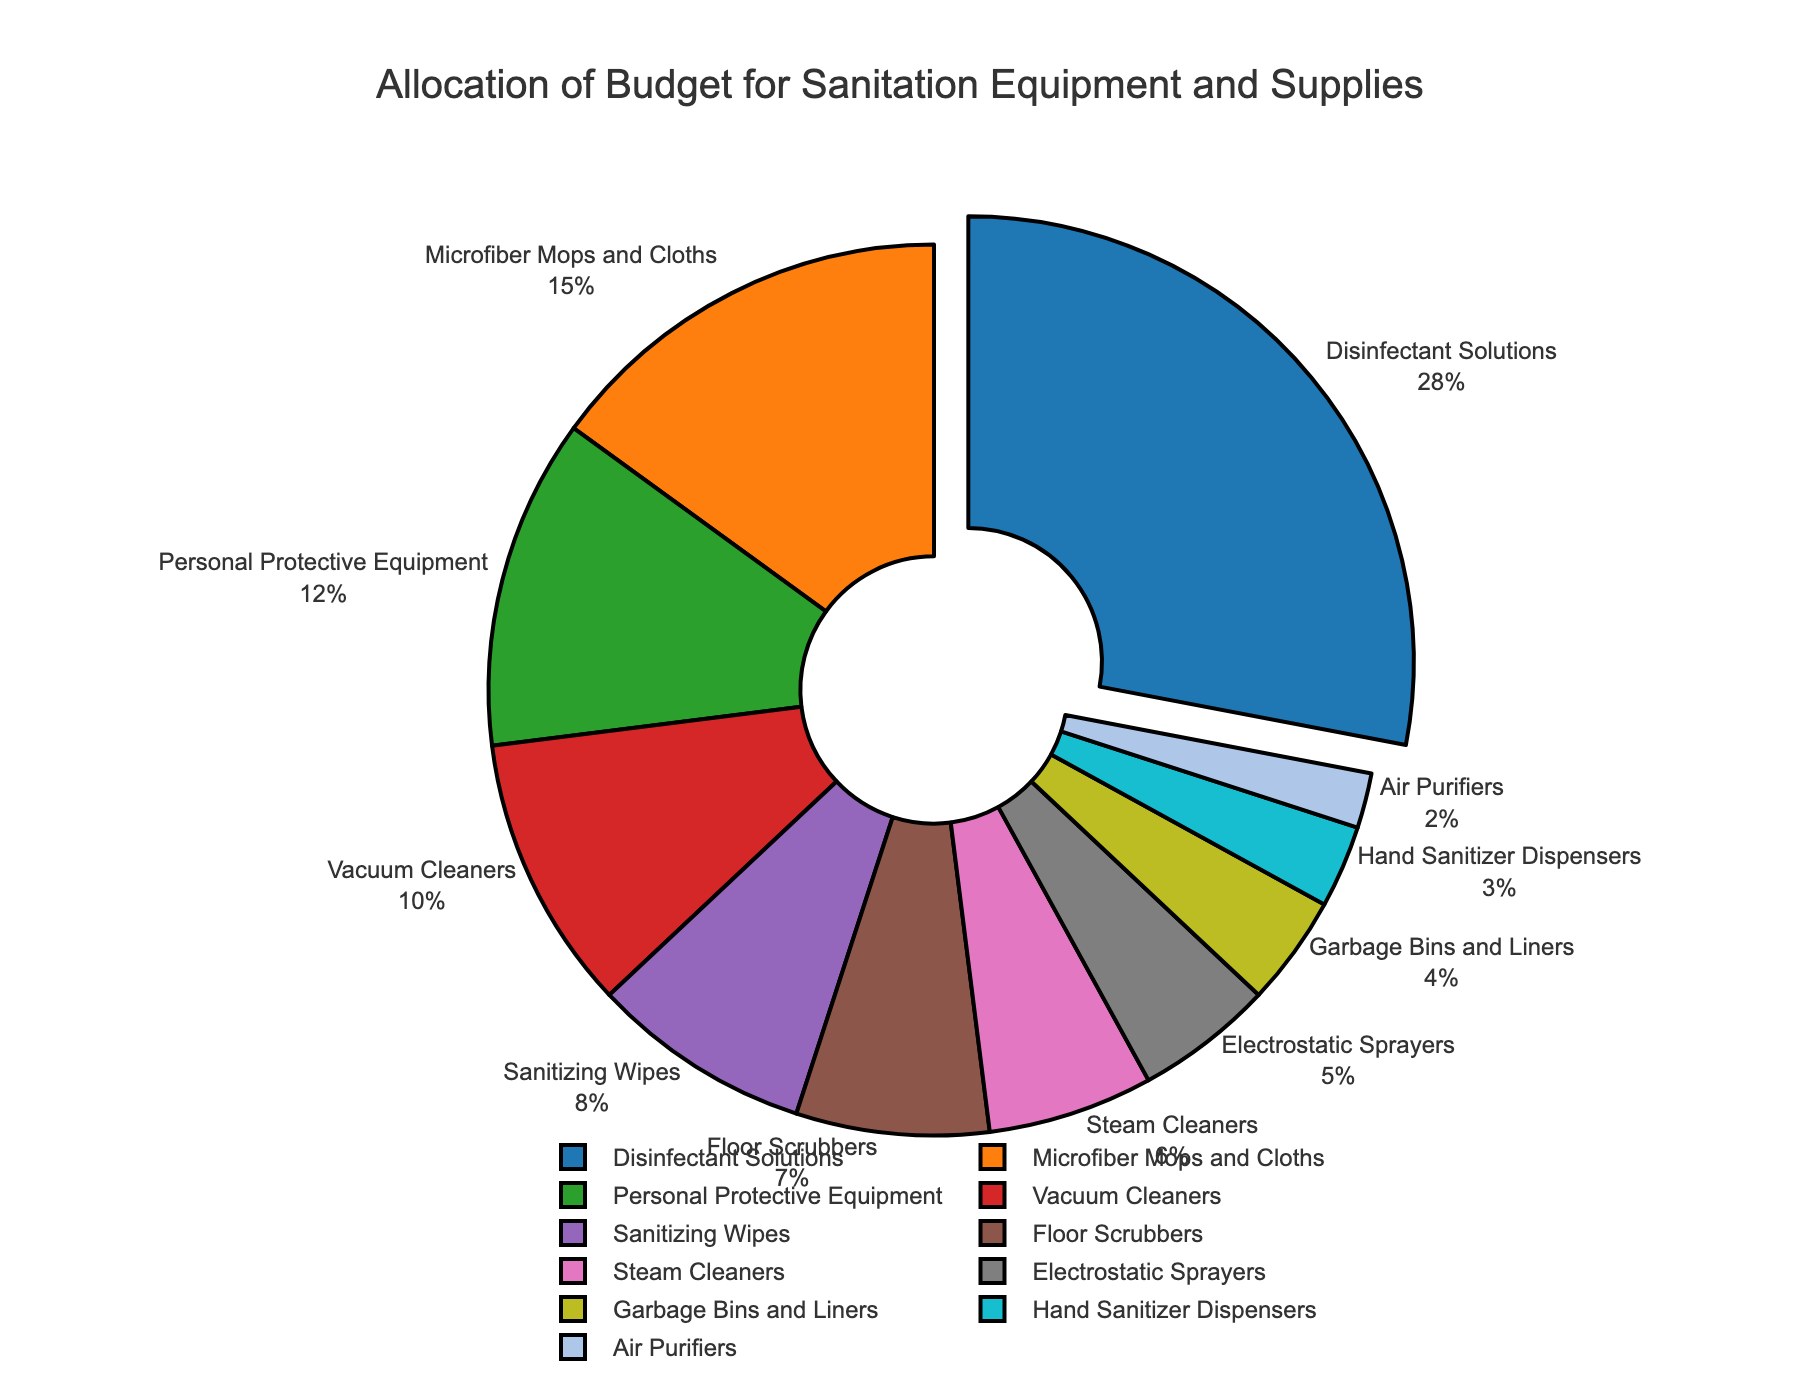What is the largest category in terms of budget allocation? The largest category can be identified by looking at the slice with the highest percentage in the pie chart. This is the category that also stands out visually due to its size.
Answer: Disinfectant Solutions Which category has the smallest allocation? To find the smallest allocation, look for the slice in the pie chart with the smallest percentage value.
Answer: Air Purifiers What is the total percentage allocated to Personal Protective Equipment and Sanitizing Wipes combined? Add the percentages of Personal Protective Equipment (12%) and Sanitizing Wipes (8%): 12 + 8 = 20%
Answer: 20% How does the allocation for Microfiber Mops and Cloths compare to Vacuum Cleaners? Compare the percentages of Microfiber Mops and Cloths (15%) and Vacuum Cleaners (10%). Microfiber Mops and Cloths have a higher percentage.
Answer: Microfiber Mops and Cloths have a higher allocation What is the combined budget percentage for all cleaning equipment (excluding disposables like wipes)? Add the percentages for Microfiber Mops and Cloths (15%), Vacuum Cleaners (10%), Floor Scrubbers (7%), Steam Cleaners (6%), and Electrostatic Sprayers (5%): 15 + 10 + 7 + 6 + 5 = 43%
Answer: 43% Which categories together make up more than half of the total budget? Add the percentages of the largest categories until their sum exceeds 50%. Disinfectant Solutions (28%) + Microfiber Mops and Cloths (15%) + Personal Protective Equipment (12%): 28 + 15 + 12 = 55%.
Answer: Disinfectant Solutions, Microfiber Mops and Cloths, Personal Protective Equipment Compare the budget allocation for Electrostatic Sprayers to Garbage Bins and Liners. Compare the percentages of Electrostatic Sprayers (5%) and Garbage Bins and Liners (4%). Electrostatic Sprayers have a higher allocation.
Answer: Electrostatic Sprayers have a higher allocation What percentage of the budget is allocated to categories with a percentage less than 5%? Sum the percentages of categories with less than 5%: Garbage Bins and Liners (4%), Hand Sanitizer Dispensers (3%), Air Purifiers (2%): 4 + 3 + 2 = 9%
Answer: 9% How much more budget percentage is allocated to Disinfectant Solutions than to Hand Sanitizer Dispensers? Subtract the percentage of Hand Sanitizer Dispensers (3%) from the percentage of Disinfectant Solutions (28%): 28 - 3 = 25%
Answer: 25% Which category represents the color blue in the pie chart? The category represented by the color blue can be identified by looking at the legend or the slice in the pie chart colored in blue.
Answer: Disinfectant Solutions 